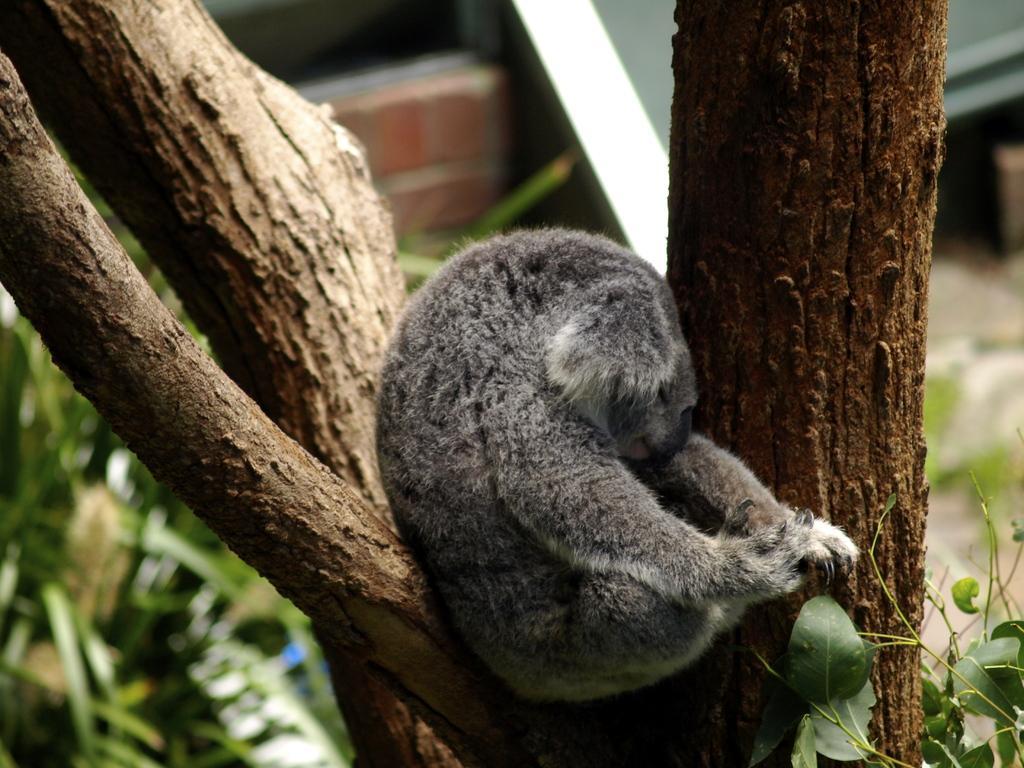Please provide a concise description of this image. In this image I can see few trees in the centre and in the front I can see a grey colour koala. I can also see green colour leaves on the both side of this image and I can see this image is little bit blurry in the background. 